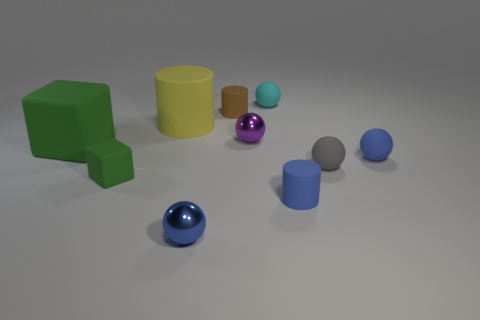Subtract all tiny blue metal spheres. How many spheres are left? 4 Subtract all purple balls. How many balls are left? 4 Subtract all yellow spheres. Subtract all blue cylinders. How many spheres are left? 5 Subtract all cylinders. How many objects are left? 7 Subtract all small blue cylinders. Subtract all cyan objects. How many objects are left? 8 Add 6 small green things. How many small green things are left? 7 Add 3 big objects. How many big objects exist? 5 Subtract 0 green cylinders. How many objects are left? 10 